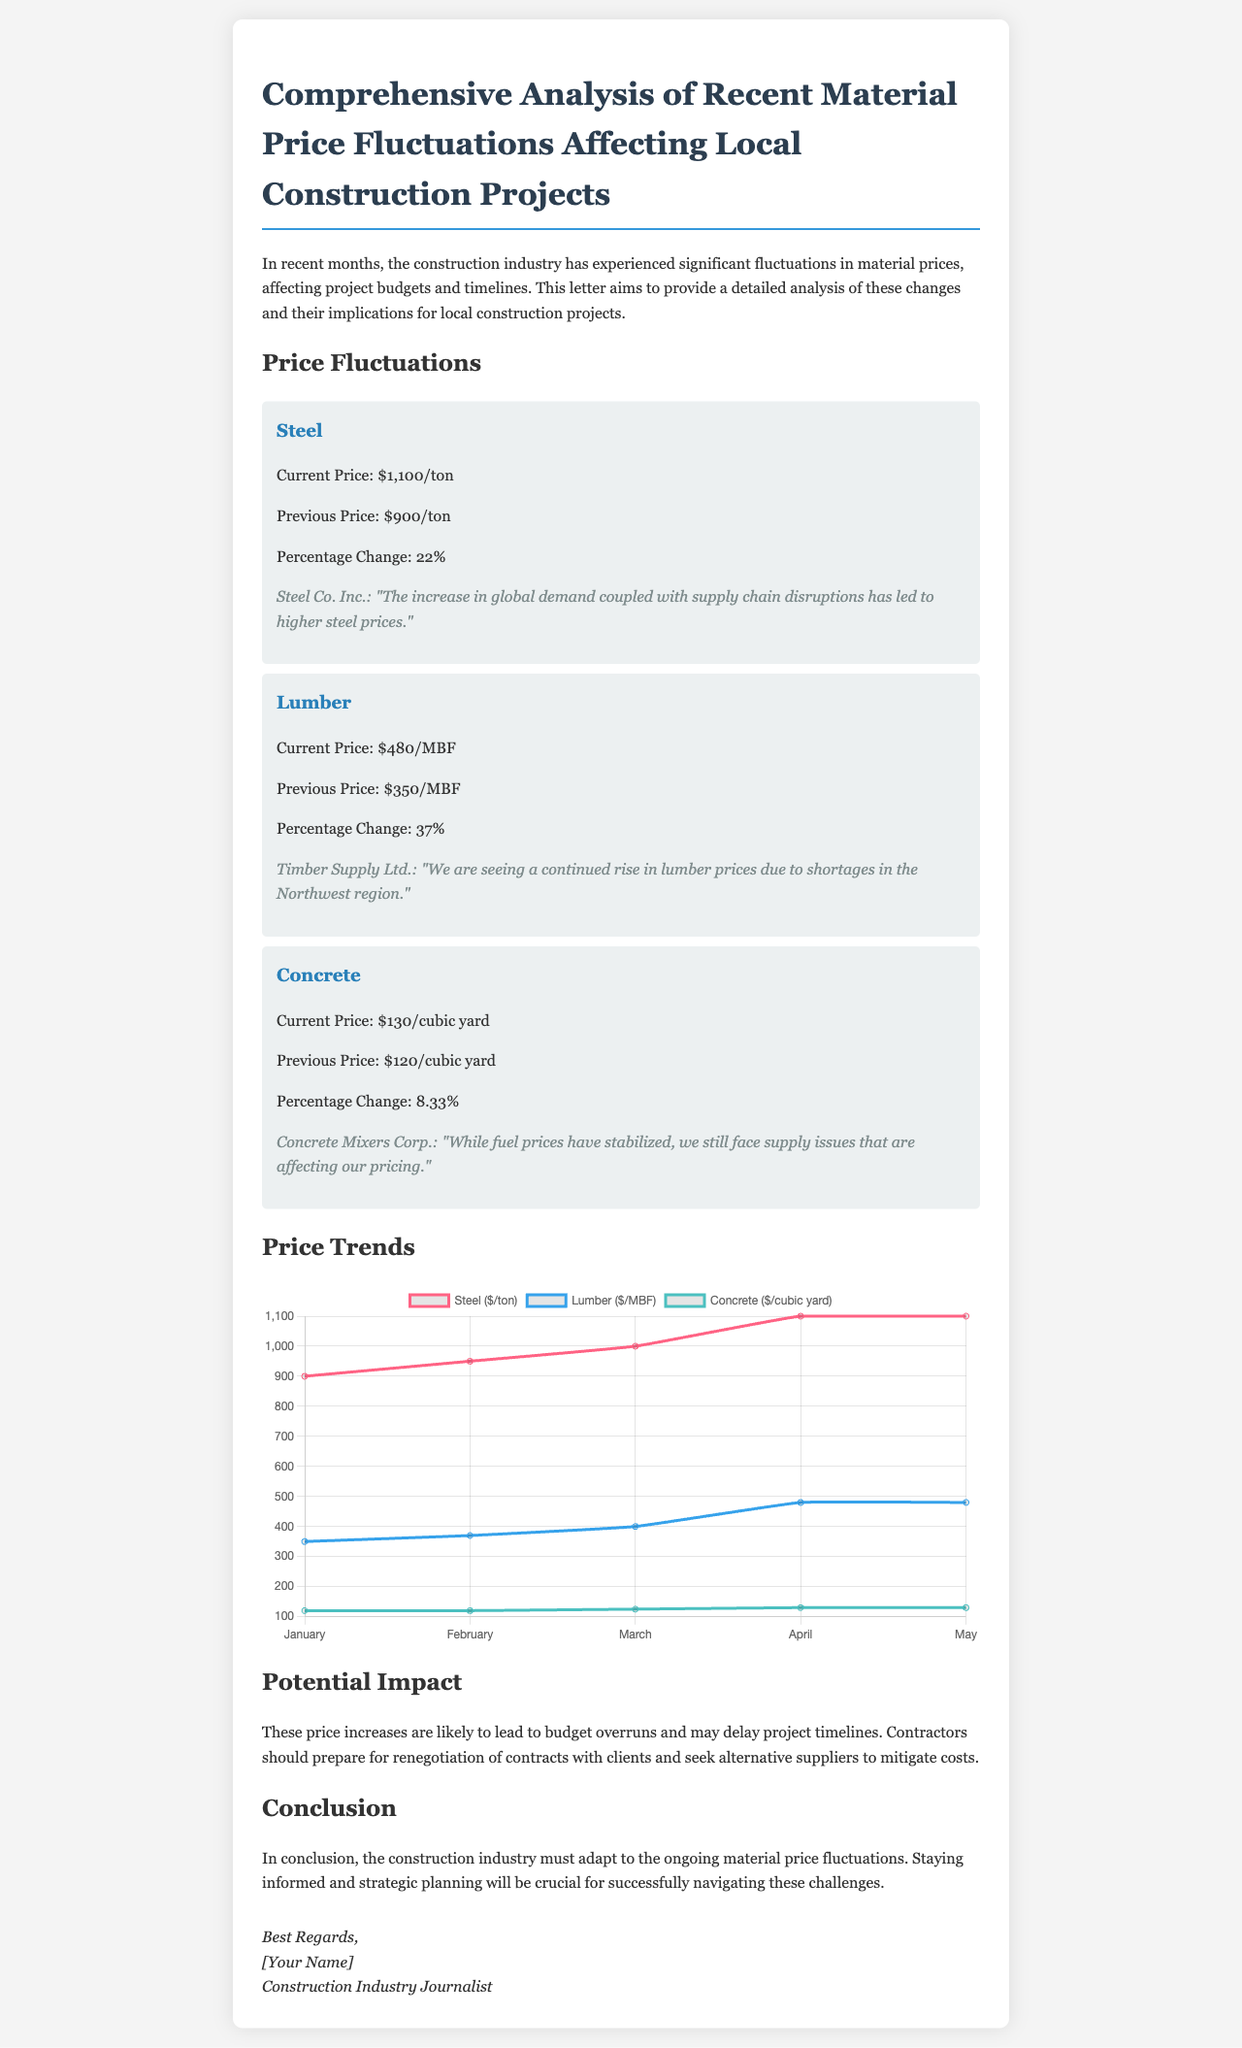What is the current price of steel? The current price of steel is stated in the document as $1,100/ton.
Answer: $1,100/ton What is the percentage change in lumber prices? The percentage change in lumber prices is indicated as 37%.
Answer: 37% Which supplier provided a quote regarding the rise in concrete prices? The supplier that provided a quote is Concrete Mixers Corp.
Answer: Concrete Mixers Corp What was the previous price of lumber? The previous price of lumber is given as $350/MBF.
Answer: $350/MBF What is the trend in concrete prices over the months shown in the chart? The trend shows a slight increase in concrete prices, peaking at $130/cubic yard in the last two months.
Answer: Slight increase What issue is suggested to potentially delay projects? The document suggests budget overruns are likely to delay project timelines due to price increases.
Answer: Budget overruns What color represents lumber in the price trend chart? Lumber is represented by the color blue in the price trend chart.
Answer: Blue How does the conclusion recommend the construction industry should adapt? The conclusion recommends staying informed and strategic planning as ways for adaptation.
Answer: Stay informed and strategic planning 